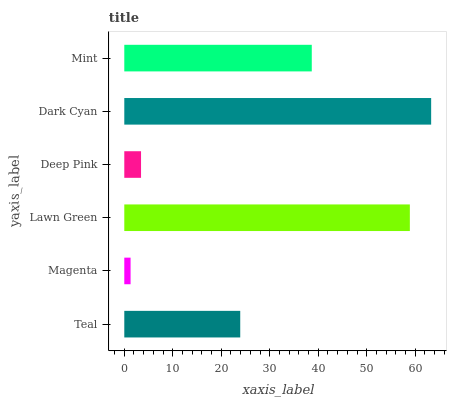Is Magenta the minimum?
Answer yes or no. Yes. Is Dark Cyan the maximum?
Answer yes or no. Yes. Is Lawn Green the minimum?
Answer yes or no. No. Is Lawn Green the maximum?
Answer yes or no. No. Is Lawn Green greater than Magenta?
Answer yes or no. Yes. Is Magenta less than Lawn Green?
Answer yes or no. Yes. Is Magenta greater than Lawn Green?
Answer yes or no. No. Is Lawn Green less than Magenta?
Answer yes or no. No. Is Mint the high median?
Answer yes or no. Yes. Is Teal the low median?
Answer yes or no. Yes. Is Dark Cyan the high median?
Answer yes or no. No. Is Lawn Green the low median?
Answer yes or no. No. 